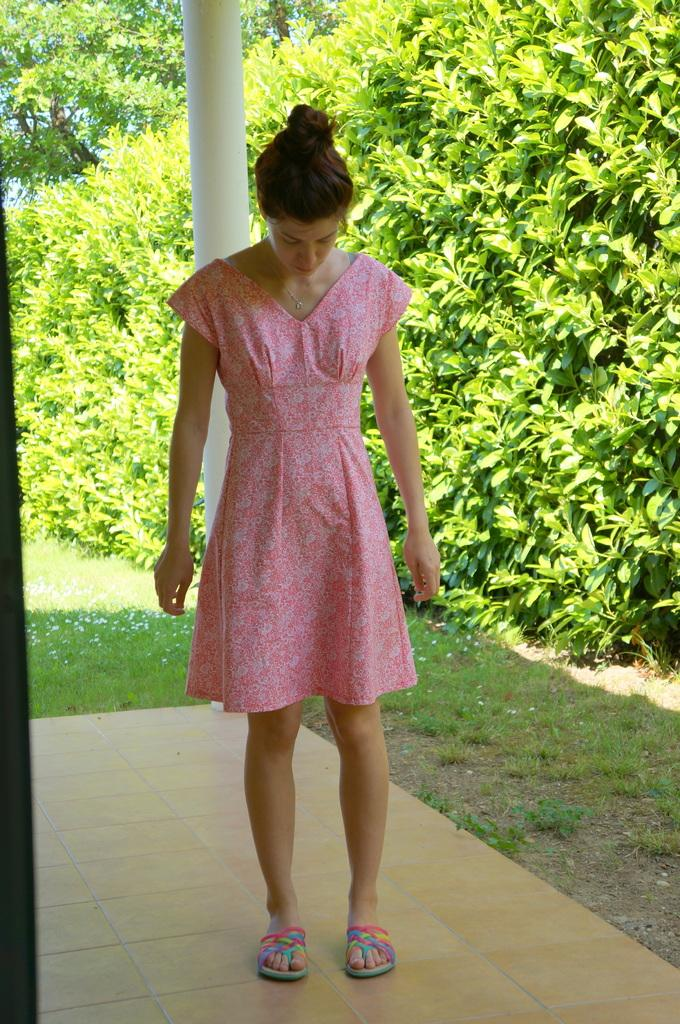What is the main subject of the image? There is a woman standing in the image. What is the woman doing in the image? The woman is looking downwards. What can be seen in the background of the image? There are trees, plants, grass, and a pole in the background of the image. What type of bell can be heard ringing in the image? There is no bell present in the image, and therefore no sound can be heard. 